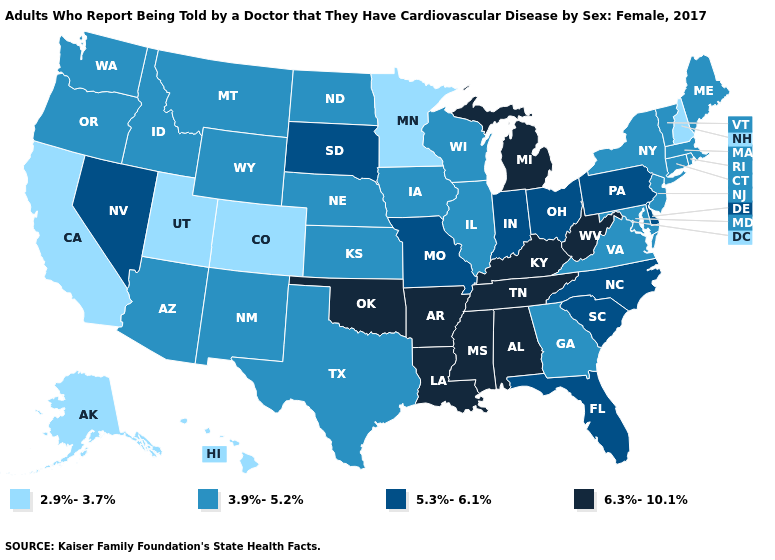Among the states that border Utah , which have the highest value?
Write a very short answer. Nevada. What is the highest value in the South ?
Answer briefly. 6.3%-10.1%. Among the states that border Missouri , which have the highest value?
Answer briefly. Arkansas, Kentucky, Oklahoma, Tennessee. Name the states that have a value in the range 3.9%-5.2%?
Quick response, please. Arizona, Connecticut, Georgia, Idaho, Illinois, Iowa, Kansas, Maine, Maryland, Massachusetts, Montana, Nebraska, New Jersey, New Mexico, New York, North Dakota, Oregon, Rhode Island, Texas, Vermont, Virginia, Washington, Wisconsin, Wyoming. Does the map have missing data?
Write a very short answer. No. Name the states that have a value in the range 3.9%-5.2%?
Answer briefly. Arizona, Connecticut, Georgia, Idaho, Illinois, Iowa, Kansas, Maine, Maryland, Massachusetts, Montana, Nebraska, New Jersey, New Mexico, New York, North Dakota, Oregon, Rhode Island, Texas, Vermont, Virginia, Washington, Wisconsin, Wyoming. Name the states that have a value in the range 6.3%-10.1%?
Quick response, please. Alabama, Arkansas, Kentucky, Louisiana, Michigan, Mississippi, Oklahoma, Tennessee, West Virginia. What is the lowest value in the Northeast?
Concise answer only. 2.9%-3.7%. Does Pennsylvania have the highest value in the USA?
Quick response, please. No. What is the value of Utah?
Quick response, please. 2.9%-3.7%. Among the states that border Tennessee , which have the highest value?
Write a very short answer. Alabama, Arkansas, Kentucky, Mississippi. What is the value of Colorado?
Concise answer only. 2.9%-3.7%. Does the map have missing data?
Quick response, please. No. What is the lowest value in the Northeast?
Give a very brief answer. 2.9%-3.7%. Name the states that have a value in the range 3.9%-5.2%?
Keep it brief. Arizona, Connecticut, Georgia, Idaho, Illinois, Iowa, Kansas, Maine, Maryland, Massachusetts, Montana, Nebraska, New Jersey, New Mexico, New York, North Dakota, Oregon, Rhode Island, Texas, Vermont, Virginia, Washington, Wisconsin, Wyoming. 